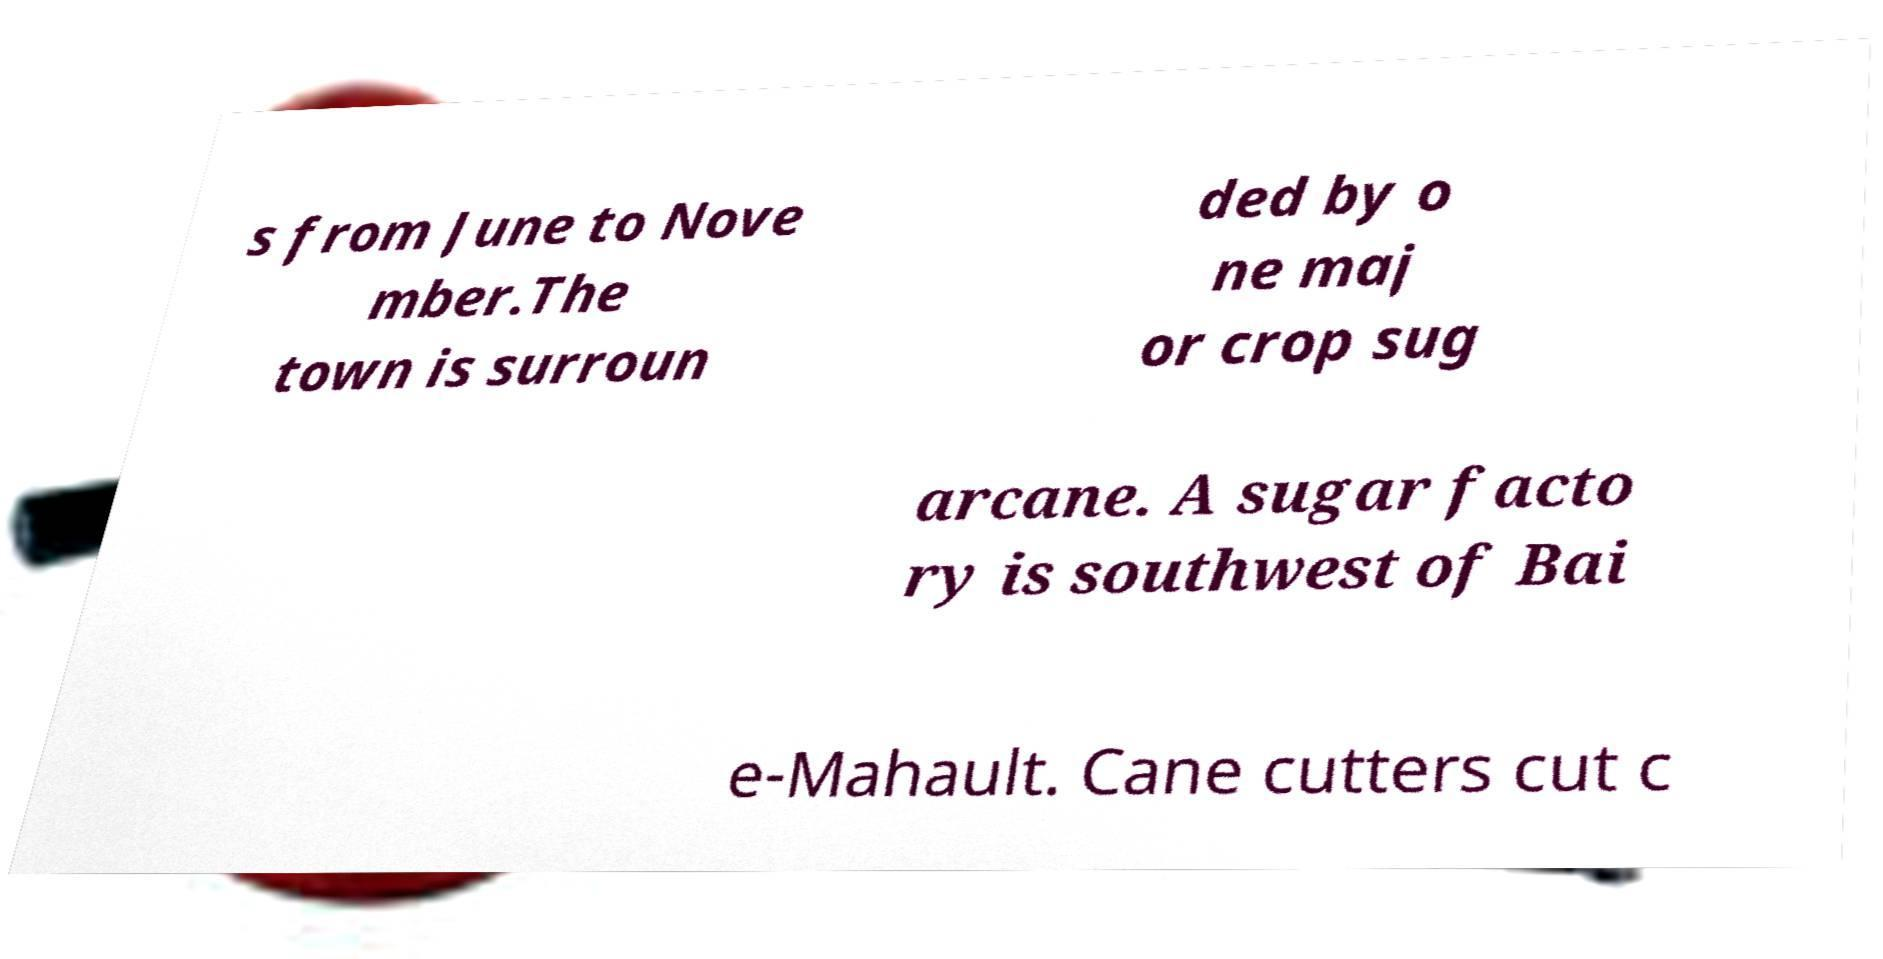I need the written content from this picture converted into text. Can you do that? s from June to Nove mber.The town is surroun ded by o ne maj or crop sug arcane. A sugar facto ry is southwest of Bai e-Mahault. Cane cutters cut c 